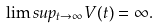Convert formula to latex. <formula><loc_0><loc_0><loc_500><loc_500>\lim s u p _ { t \rightarrow \infty } V ( t ) = \infty .</formula> 